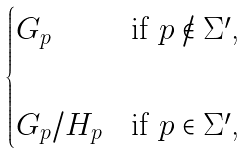<formula> <loc_0><loc_0><loc_500><loc_500>\begin{cases} G _ { p } & \text {if $p\not\in \Sigma^{\prime}$,} \\ & \\ G _ { p } / H _ { p } & \text {if $p\in \Sigma^{\prime}$,} \end{cases}</formula> 